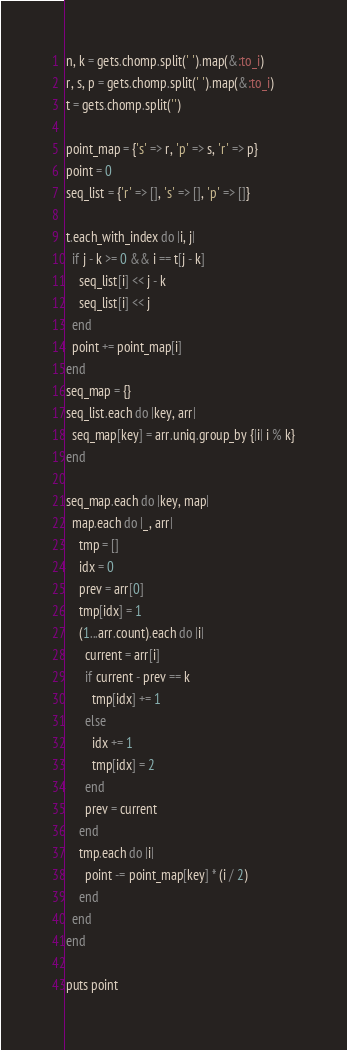<code> <loc_0><loc_0><loc_500><loc_500><_Ruby_>n, k = gets.chomp.split(' ').map(&:to_i)
r, s, p = gets.chomp.split(' ').map(&:to_i)
t = gets.chomp.split('')

point_map = {'s' => r, 'p' => s, 'r' => p}
point = 0
seq_list = {'r' => [], 's' => [], 'p' => []}

t.each_with_index do |i, j|
  if j - k >= 0 && i == t[j - k]
    seq_list[i] << j - k
    seq_list[i] << j
  end
  point += point_map[i]
end
seq_map = {}
seq_list.each do |key, arr|
  seq_map[key] = arr.uniq.group_by {|i| i % k}
end

seq_map.each do |key, map|
  map.each do |_, arr|
    tmp = []
    idx = 0
    prev = arr[0]
    tmp[idx] = 1
    (1...arr.count).each do |i|
      current = arr[i]
      if current - prev == k
        tmp[idx] += 1
      else
        idx += 1
        tmp[idx] = 2
      end
      prev = current
    end
    tmp.each do |i|
      point -= point_map[key] * (i / 2)
    end
  end
end

puts point</code> 